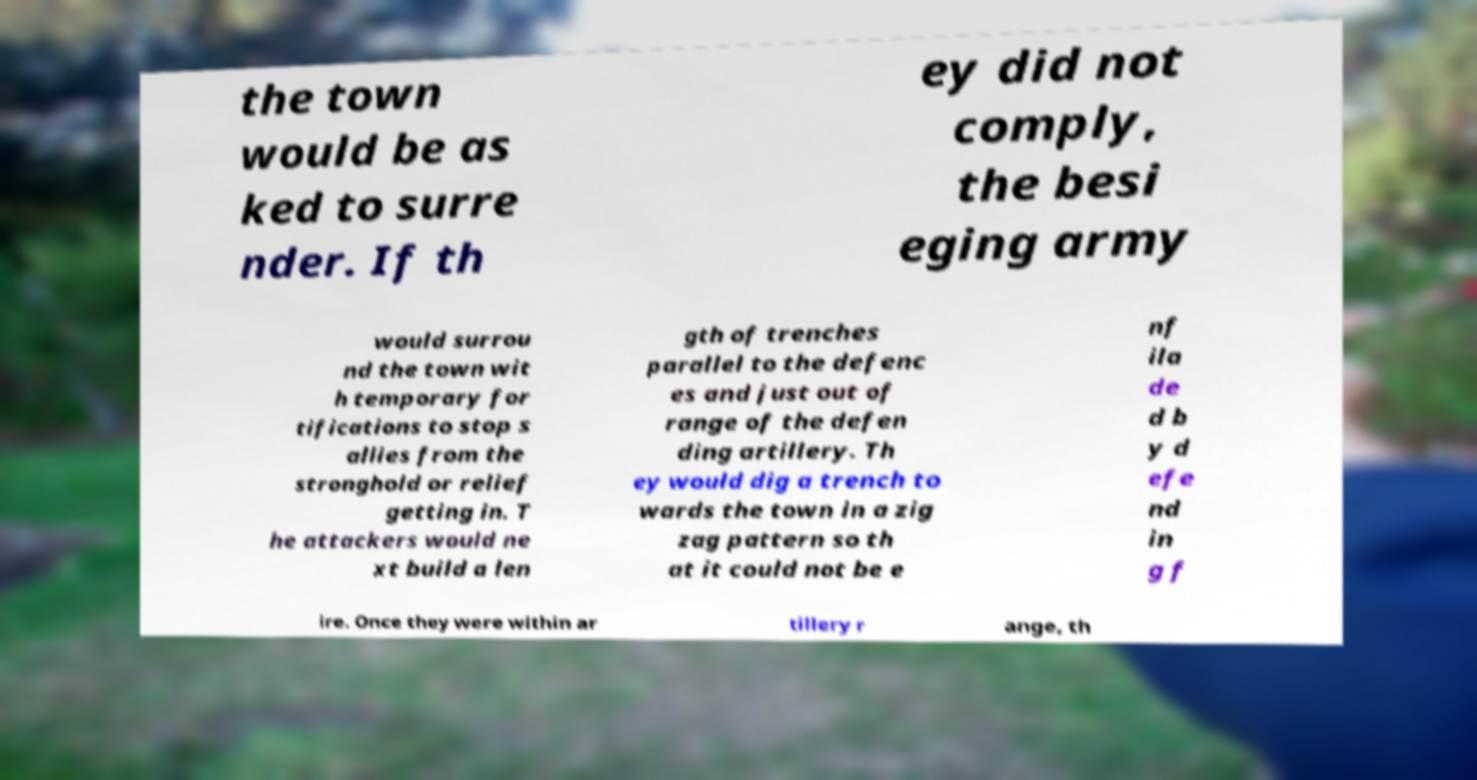Can you accurately transcribe the text from the provided image for me? the town would be as ked to surre nder. If th ey did not comply, the besi eging army would surrou nd the town wit h temporary for tifications to stop s allies from the stronghold or relief getting in. T he attackers would ne xt build a len gth of trenches parallel to the defenc es and just out of range of the defen ding artillery. Th ey would dig a trench to wards the town in a zig zag pattern so th at it could not be e nf ila de d b y d efe nd in g f ire. Once they were within ar tillery r ange, th 